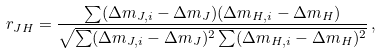<formula> <loc_0><loc_0><loc_500><loc_500>r _ { J H } = \frac { \sum ( \Delta m _ { J , i } - \Delta m _ { J } ) ( \Delta m _ { H , i } - \Delta m _ { H } ) } { \sqrt { \sum ( \Delta m _ { J , i } - \Delta m _ { J } ) ^ { 2 } \sum ( \Delta m _ { H , i } - \Delta m _ { H } ) ^ { 2 } } } \, ,</formula> 